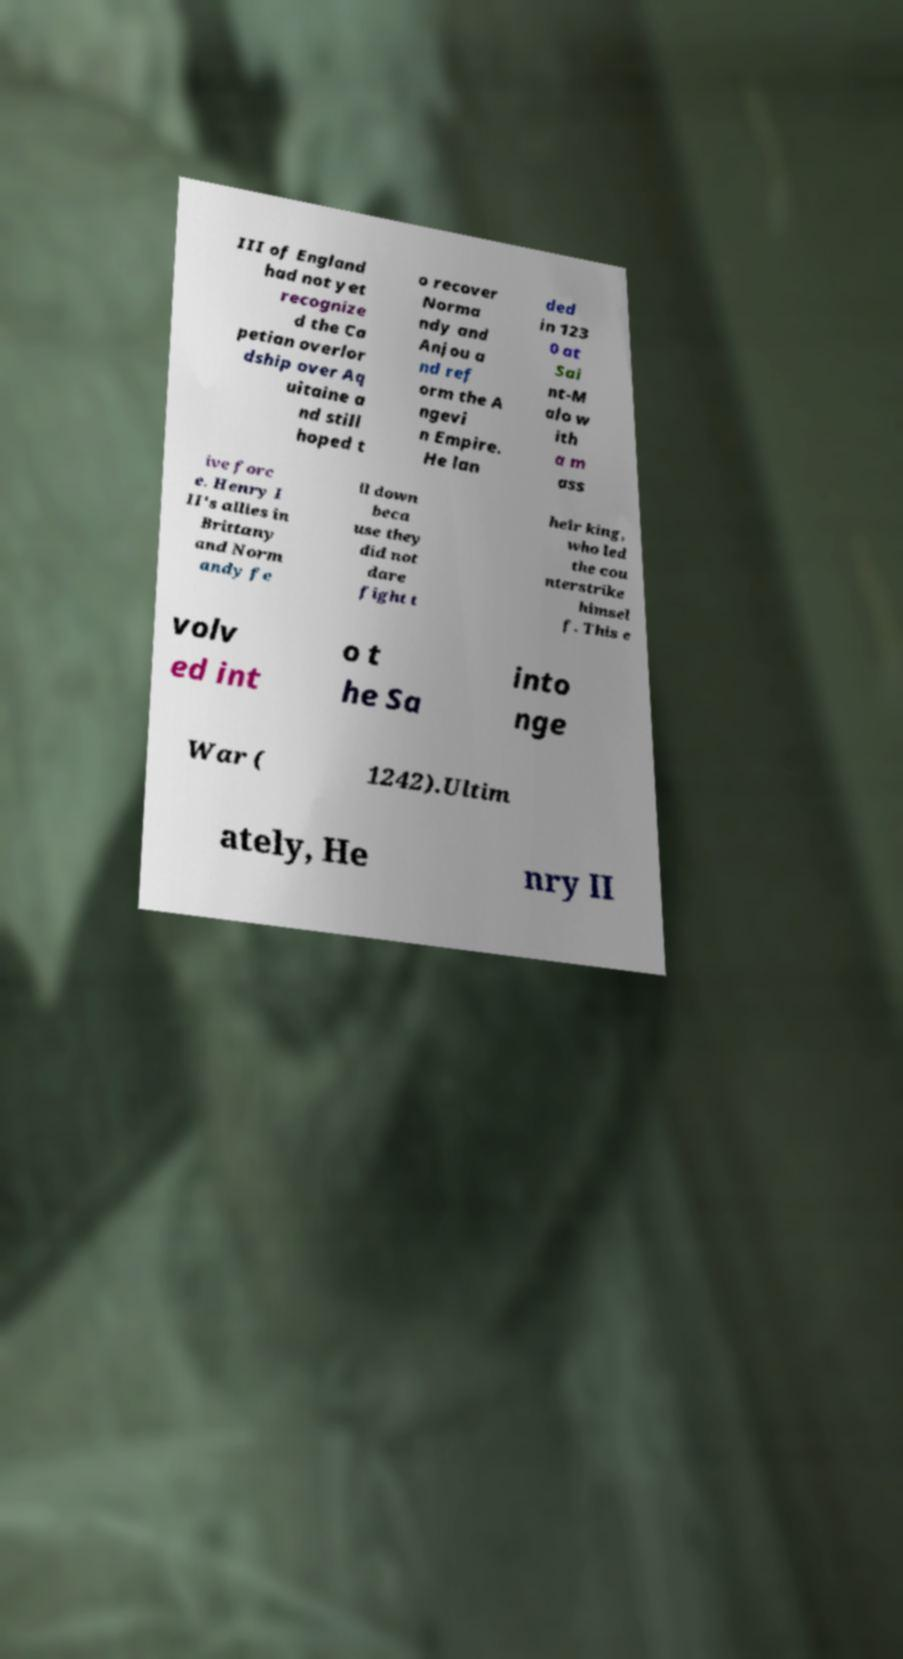What messages or text are displayed in this image? I need them in a readable, typed format. III of England had not yet recognize d the Ca petian overlor dship over Aq uitaine a nd still hoped t o recover Norma ndy and Anjou a nd ref orm the A ngevi n Empire. He lan ded in 123 0 at Sai nt-M alo w ith a m ass ive forc e. Henry I II's allies in Brittany and Norm andy fe ll down beca use they did not dare fight t heir king, who led the cou nterstrike himsel f. This e volv ed int o t he Sa into nge War ( 1242).Ultim ately, He nry II 